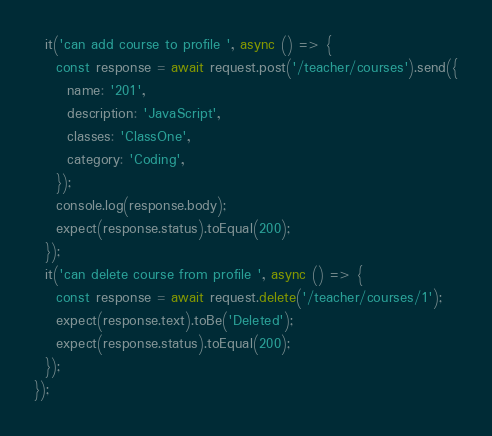<code> <loc_0><loc_0><loc_500><loc_500><_JavaScript_>  it('can add course to profile ', async () => {
    const response = await request.post('/teacher/courses').send({
      name: '201',
      description: 'JavaScript',
      classes: 'ClassOne',
      category: 'Coding',
    });
    console.log(response.body);
    expect(response.status).toEqual(200);
  });
  it('can delete course from profile ', async () => {
    const response = await request.delete('/teacher/courses/1');
    expect(response.text).toBe('Deleted');
    expect(response.status).toEqual(200);
  });
});
</code> 